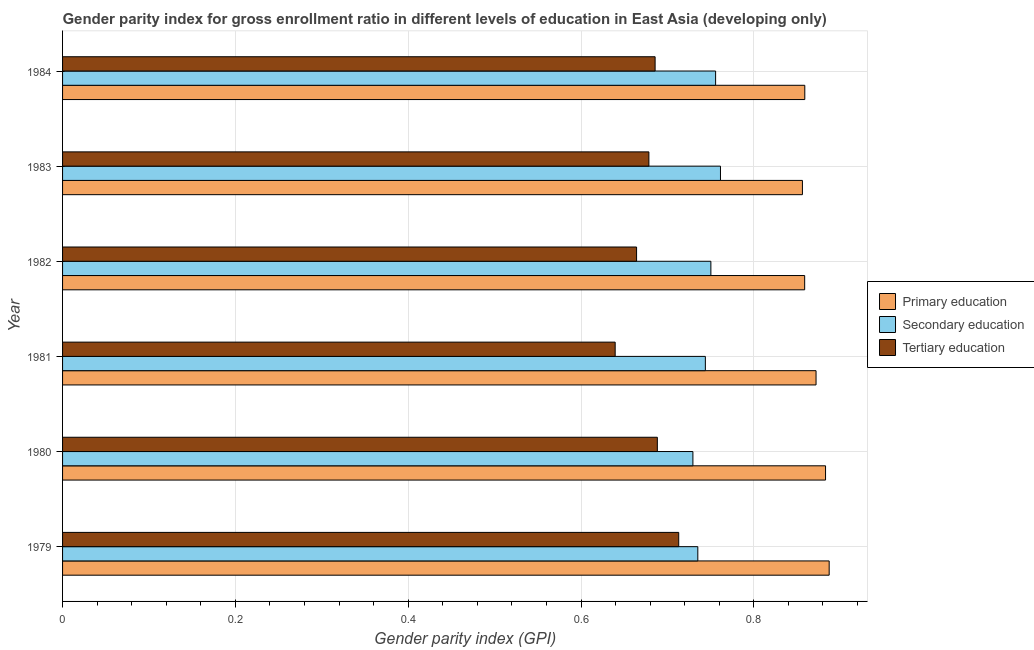Are the number of bars on each tick of the Y-axis equal?
Make the answer very short. Yes. How many bars are there on the 3rd tick from the top?
Give a very brief answer. 3. What is the label of the 1st group of bars from the top?
Provide a succinct answer. 1984. In how many cases, is the number of bars for a given year not equal to the number of legend labels?
Give a very brief answer. 0. What is the gender parity index in tertiary education in 1984?
Provide a succinct answer. 0.69. Across all years, what is the maximum gender parity index in secondary education?
Ensure brevity in your answer.  0.76. Across all years, what is the minimum gender parity index in primary education?
Make the answer very short. 0.86. In which year was the gender parity index in secondary education maximum?
Provide a short and direct response. 1983. What is the total gender parity index in secondary education in the graph?
Your answer should be compact. 4.48. What is the difference between the gender parity index in tertiary education in 1981 and that in 1984?
Keep it short and to the point. -0.05. What is the difference between the gender parity index in tertiary education in 1980 and the gender parity index in primary education in 1982?
Keep it short and to the point. -0.17. What is the average gender parity index in tertiary education per year?
Offer a very short reply. 0.68. In the year 1982, what is the difference between the gender parity index in primary education and gender parity index in tertiary education?
Provide a short and direct response. 0.2. In how many years, is the gender parity index in tertiary education greater than 0.6000000000000001 ?
Your answer should be compact. 6. What is the ratio of the gender parity index in tertiary education in 1981 to that in 1982?
Ensure brevity in your answer.  0.96. Is the gender parity index in tertiary education in 1979 less than that in 1980?
Provide a succinct answer. No. Is the difference between the gender parity index in tertiary education in 1979 and 1984 greater than the difference between the gender parity index in secondary education in 1979 and 1984?
Keep it short and to the point. Yes. What is the difference between the highest and the second highest gender parity index in primary education?
Your answer should be compact. 0. What is the difference between the highest and the lowest gender parity index in tertiary education?
Give a very brief answer. 0.07. In how many years, is the gender parity index in secondary education greater than the average gender parity index in secondary education taken over all years?
Make the answer very short. 3. What does the 2nd bar from the top in 1980 represents?
Your response must be concise. Secondary education. What does the 1st bar from the bottom in 1984 represents?
Provide a succinct answer. Primary education. Is it the case that in every year, the sum of the gender parity index in primary education and gender parity index in secondary education is greater than the gender parity index in tertiary education?
Ensure brevity in your answer.  Yes. How many bars are there?
Your answer should be compact. 18. Are all the bars in the graph horizontal?
Provide a succinct answer. Yes. Where does the legend appear in the graph?
Provide a short and direct response. Center right. How many legend labels are there?
Your answer should be compact. 3. How are the legend labels stacked?
Provide a short and direct response. Vertical. What is the title of the graph?
Your answer should be compact. Gender parity index for gross enrollment ratio in different levels of education in East Asia (developing only). What is the label or title of the X-axis?
Keep it short and to the point. Gender parity index (GPI). What is the Gender parity index (GPI) of Primary education in 1979?
Offer a very short reply. 0.89. What is the Gender parity index (GPI) in Secondary education in 1979?
Offer a terse response. 0.74. What is the Gender parity index (GPI) in Tertiary education in 1979?
Provide a succinct answer. 0.71. What is the Gender parity index (GPI) of Primary education in 1980?
Provide a succinct answer. 0.88. What is the Gender parity index (GPI) of Secondary education in 1980?
Provide a succinct answer. 0.73. What is the Gender parity index (GPI) of Tertiary education in 1980?
Make the answer very short. 0.69. What is the Gender parity index (GPI) of Primary education in 1981?
Offer a terse response. 0.87. What is the Gender parity index (GPI) in Secondary education in 1981?
Make the answer very short. 0.74. What is the Gender parity index (GPI) of Tertiary education in 1981?
Provide a succinct answer. 0.64. What is the Gender parity index (GPI) in Primary education in 1982?
Make the answer very short. 0.86. What is the Gender parity index (GPI) of Secondary education in 1982?
Your response must be concise. 0.75. What is the Gender parity index (GPI) in Tertiary education in 1982?
Your answer should be compact. 0.66. What is the Gender parity index (GPI) in Primary education in 1983?
Make the answer very short. 0.86. What is the Gender parity index (GPI) of Secondary education in 1983?
Keep it short and to the point. 0.76. What is the Gender parity index (GPI) of Tertiary education in 1983?
Your answer should be very brief. 0.68. What is the Gender parity index (GPI) in Primary education in 1984?
Offer a very short reply. 0.86. What is the Gender parity index (GPI) of Secondary education in 1984?
Make the answer very short. 0.76. What is the Gender parity index (GPI) of Tertiary education in 1984?
Provide a short and direct response. 0.69. Across all years, what is the maximum Gender parity index (GPI) in Primary education?
Your answer should be compact. 0.89. Across all years, what is the maximum Gender parity index (GPI) in Secondary education?
Give a very brief answer. 0.76. Across all years, what is the maximum Gender parity index (GPI) of Tertiary education?
Provide a succinct answer. 0.71. Across all years, what is the minimum Gender parity index (GPI) in Primary education?
Provide a short and direct response. 0.86. Across all years, what is the minimum Gender parity index (GPI) in Secondary education?
Offer a terse response. 0.73. Across all years, what is the minimum Gender parity index (GPI) in Tertiary education?
Give a very brief answer. 0.64. What is the total Gender parity index (GPI) in Primary education in the graph?
Ensure brevity in your answer.  5.22. What is the total Gender parity index (GPI) of Secondary education in the graph?
Keep it short and to the point. 4.48. What is the total Gender parity index (GPI) in Tertiary education in the graph?
Make the answer very short. 4.07. What is the difference between the Gender parity index (GPI) of Primary education in 1979 and that in 1980?
Ensure brevity in your answer.  0. What is the difference between the Gender parity index (GPI) in Secondary education in 1979 and that in 1980?
Give a very brief answer. 0.01. What is the difference between the Gender parity index (GPI) in Tertiary education in 1979 and that in 1980?
Keep it short and to the point. 0.02. What is the difference between the Gender parity index (GPI) in Primary education in 1979 and that in 1981?
Ensure brevity in your answer.  0.02. What is the difference between the Gender parity index (GPI) of Secondary education in 1979 and that in 1981?
Give a very brief answer. -0.01. What is the difference between the Gender parity index (GPI) in Tertiary education in 1979 and that in 1981?
Give a very brief answer. 0.07. What is the difference between the Gender parity index (GPI) of Primary education in 1979 and that in 1982?
Your answer should be compact. 0.03. What is the difference between the Gender parity index (GPI) in Secondary education in 1979 and that in 1982?
Ensure brevity in your answer.  -0.02. What is the difference between the Gender parity index (GPI) in Tertiary education in 1979 and that in 1982?
Keep it short and to the point. 0.05. What is the difference between the Gender parity index (GPI) in Primary education in 1979 and that in 1983?
Offer a terse response. 0.03. What is the difference between the Gender parity index (GPI) of Secondary education in 1979 and that in 1983?
Ensure brevity in your answer.  -0.03. What is the difference between the Gender parity index (GPI) of Tertiary education in 1979 and that in 1983?
Your answer should be compact. 0.03. What is the difference between the Gender parity index (GPI) of Primary education in 1979 and that in 1984?
Offer a very short reply. 0.03. What is the difference between the Gender parity index (GPI) in Secondary education in 1979 and that in 1984?
Provide a succinct answer. -0.02. What is the difference between the Gender parity index (GPI) of Tertiary education in 1979 and that in 1984?
Provide a short and direct response. 0.03. What is the difference between the Gender parity index (GPI) of Primary education in 1980 and that in 1981?
Ensure brevity in your answer.  0.01. What is the difference between the Gender parity index (GPI) in Secondary education in 1980 and that in 1981?
Your response must be concise. -0.01. What is the difference between the Gender parity index (GPI) of Tertiary education in 1980 and that in 1981?
Give a very brief answer. 0.05. What is the difference between the Gender parity index (GPI) in Primary education in 1980 and that in 1982?
Offer a very short reply. 0.02. What is the difference between the Gender parity index (GPI) in Secondary education in 1980 and that in 1982?
Keep it short and to the point. -0.02. What is the difference between the Gender parity index (GPI) in Tertiary education in 1980 and that in 1982?
Keep it short and to the point. 0.02. What is the difference between the Gender parity index (GPI) in Primary education in 1980 and that in 1983?
Keep it short and to the point. 0.03. What is the difference between the Gender parity index (GPI) of Secondary education in 1980 and that in 1983?
Ensure brevity in your answer.  -0.03. What is the difference between the Gender parity index (GPI) of Tertiary education in 1980 and that in 1983?
Give a very brief answer. 0.01. What is the difference between the Gender parity index (GPI) in Primary education in 1980 and that in 1984?
Provide a short and direct response. 0.02. What is the difference between the Gender parity index (GPI) in Secondary education in 1980 and that in 1984?
Give a very brief answer. -0.03. What is the difference between the Gender parity index (GPI) of Tertiary education in 1980 and that in 1984?
Offer a terse response. 0. What is the difference between the Gender parity index (GPI) in Primary education in 1981 and that in 1982?
Ensure brevity in your answer.  0.01. What is the difference between the Gender parity index (GPI) of Secondary education in 1981 and that in 1982?
Your answer should be very brief. -0.01. What is the difference between the Gender parity index (GPI) of Tertiary education in 1981 and that in 1982?
Your response must be concise. -0.02. What is the difference between the Gender parity index (GPI) in Primary education in 1981 and that in 1983?
Ensure brevity in your answer.  0.02. What is the difference between the Gender parity index (GPI) of Secondary education in 1981 and that in 1983?
Offer a terse response. -0.02. What is the difference between the Gender parity index (GPI) of Tertiary education in 1981 and that in 1983?
Make the answer very short. -0.04. What is the difference between the Gender parity index (GPI) in Primary education in 1981 and that in 1984?
Ensure brevity in your answer.  0.01. What is the difference between the Gender parity index (GPI) of Secondary education in 1981 and that in 1984?
Provide a succinct answer. -0.01. What is the difference between the Gender parity index (GPI) of Tertiary education in 1981 and that in 1984?
Provide a succinct answer. -0.05. What is the difference between the Gender parity index (GPI) in Primary education in 1982 and that in 1983?
Keep it short and to the point. 0. What is the difference between the Gender parity index (GPI) of Secondary education in 1982 and that in 1983?
Ensure brevity in your answer.  -0.01. What is the difference between the Gender parity index (GPI) in Tertiary education in 1982 and that in 1983?
Keep it short and to the point. -0.01. What is the difference between the Gender parity index (GPI) in Primary education in 1982 and that in 1984?
Provide a short and direct response. -0. What is the difference between the Gender parity index (GPI) in Secondary education in 1982 and that in 1984?
Keep it short and to the point. -0.01. What is the difference between the Gender parity index (GPI) of Tertiary education in 1982 and that in 1984?
Offer a terse response. -0.02. What is the difference between the Gender parity index (GPI) of Primary education in 1983 and that in 1984?
Your answer should be compact. -0. What is the difference between the Gender parity index (GPI) of Secondary education in 1983 and that in 1984?
Offer a very short reply. 0.01. What is the difference between the Gender parity index (GPI) in Tertiary education in 1983 and that in 1984?
Keep it short and to the point. -0.01. What is the difference between the Gender parity index (GPI) of Primary education in 1979 and the Gender parity index (GPI) of Secondary education in 1980?
Give a very brief answer. 0.16. What is the difference between the Gender parity index (GPI) in Primary education in 1979 and the Gender parity index (GPI) in Tertiary education in 1980?
Your answer should be compact. 0.2. What is the difference between the Gender parity index (GPI) of Secondary education in 1979 and the Gender parity index (GPI) of Tertiary education in 1980?
Give a very brief answer. 0.05. What is the difference between the Gender parity index (GPI) of Primary education in 1979 and the Gender parity index (GPI) of Secondary education in 1981?
Offer a very short reply. 0.14. What is the difference between the Gender parity index (GPI) of Primary education in 1979 and the Gender parity index (GPI) of Tertiary education in 1981?
Provide a short and direct response. 0.25. What is the difference between the Gender parity index (GPI) of Secondary education in 1979 and the Gender parity index (GPI) of Tertiary education in 1981?
Your response must be concise. 0.1. What is the difference between the Gender parity index (GPI) in Primary education in 1979 and the Gender parity index (GPI) in Secondary education in 1982?
Your answer should be very brief. 0.14. What is the difference between the Gender parity index (GPI) in Primary education in 1979 and the Gender parity index (GPI) in Tertiary education in 1982?
Provide a succinct answer. 0.22. What is the difference between the Gender parity index (GPI) of Secondary education in 1979 and the Gender parity index (GPI) of Tertiary education in 1982?
Keep it short and to the point. 0.07. What is the difference between the Gender parity index (GPI) in Primary education in 1979 and the Gender parity index (GPI) in Secondary education in 1983?
Offer a terse response. 0.13. What is the difference between the Gender parity index (GPI) in Primary education in 1979 and the Gender parity index (GPI) in Tertiary education in 1983?
Offer a terse response. 0.21. What is the difference between the Gender parity index (GPI) in Secondary education in 1979 and the Gender parity index (GPI) in Tertiary education in 1983?
Keep it short and to the point. 0.06. What is the difference between the Gender parity index (GPI) of Primary education in 1979 and the Gender parity index (GPI) of Secondary education in 1984?
Offer a very short reply. 0.13. What is the difference between the Gender parity index (GPI) in Primary education in 1979 and the Gender parity index (GPI) in Tertiary education in 1984?
Provide a short and direct response. 0.2. What is the difference between the Gender parity index (GPI) of Secondary education in 1979 and the Gender parity index (GPI) of Tertiary education in 1984?
Provide a short and direct response. 0.05. What is the difference between the Gender parity index (GPI) of Primary education in 1980 and the Gender parity index (GPI) of Secondary education in 1981?
Make the answer very short. 0.14. What is the difference between the Gender parity index (GPI) of Primary education in 1980 and the Gender parity index (GPI) of Tertiary education in 1981?
Keep it short and to the point. 0.24. What is the difference between the Gender parity index (GPI) of Secondary education in 1980 and the Gender parity index (GPI) of Tertiary education in 1981?
Offer a very short reply. 0.09. What is the difference between the Gender parity index (GPI) of Primary education in 1980 and the Gender parity index (GPI) of Secondary education in 1982?
Offer a terse response. 0.13. What is the difference between the Gender parity index (GPI) in Primary education in 1980 and the Gender parity index (GPI) in Tertiary education in 1982?
Ensure brevity in your answer.  0.22. What is the difference between the Gender parity index (GPI) of Secondary education in 1980 and the Gender parity index (GPI) of Tertiary education in 1982?
Your response must be concise. 0.07. What is the difference between the Gender parity index (GPI) in Primary education in 1980 and the Gender parity index (GPI) in Secondary education in 1983?
Make the answer very short. 0.12. What is the difference between the Gender parity index (GPI) in Primary education in 1980 and the Gender parity index (GPI) in Tertiary education in 1983?
Ensure brevity in your answer.  0.2. What is the difference between the Gender parity index (GPI) in Secondary education in 1980 and the Gender parity index (GPI) in Tertiary education in 1983?
Your answer should be compact. 0.05. What is the difference between the Gender parity index (GPI) of Primary education in 1980 and the Gender parity index (GPI) of Secondary education in 1984?
Give a very brief answer. 0.13. What is the difference between the Gender parity index (GPI) in Primary education in 1980 and the Gender parity index (GPI) in Tertiary education in 1984?
Provide a short and direct response. 0.2. What is the difference between the Gender parity index (GPI) of Secondary education in 1980 and the Gender parity index (GPI) of Tertiary education in 1984?
Provide a short and direct response. 0.04. What is the difference between the Gender parity index (GPI) of Primary education in 1981 and the Gender parity index (GPI) of Secondary education in 1982?
Keep it short and to the point. 0.12. What is the difference between the Gender parity index (GPI) in Primary education in 1981 and the Gender parity index (GPI) in Tertiary education in 1982?
Your answer should be very brief. 0.21. What is the difference between the Gender parity index (GPI) of Secondary education in 1981 and the Gender parity index (GPI) of Tertiary education in 1982?
Offer a terse response. 0.08. What is the difference between the Gender parity index (GPI) of Primary education in 1981 and the Gender parity index (GPI) of Secondary education in 1983?
Your answer should be compact. 0.11. What is the difference between the Gender parity index (GPI) in Primary education in 1981 and the Gender parity index (GPI) in Tertiary education in 1983?
Give a very brief answer. 0.19. What is the difference between the Gender parity index (GPI) in Secondary education in 1981 and the Gender parity index (GPI) in Tertiary education in 1983?
Your response must be concise. 0.07. What is the difference between the Gender parity index (GPI) in Primary education in 1981 and the Gender parity index (GPI) in Secondary education in 1984?
Give a very brief answer. 0.12. What is the difference between the Gender parity index (GPI) of Primary education in 1981 and the Gender parity index (GPI) of Tertiary education in 1984?
Your response must be concise. 0.19. What is the difference between the Gender parity index (GPI) of Secondary education in 1981 and the Gender parity index (GPI) of Tertiary education in 1984?
Give a very brief answer. 0.06. What is the difference between the Gender parity index (GPI) of Primary education in 1982 and the Gender parity index (GPI) of Secondary education in 1983?
Provide a short and direct response. 0.1. What is the difference between the Gender parity index (GPI) of Primary education in 1982 and the Gender parity index (GPI) of Tertiary education in 1983?
Offer a terse response. 0.18. What is the difference between the Gender parity index (GPI) in Secondary education in 1982 and the Gender parity index (GPI) in Tertiary education in 1983?
Ensure brevity in your answer.  0.07. What is the difference between the Gender parity index (GPI) of Primary education in 1982 and the Gender parity index (GPI) of Secondary education in 1984?
Make the answer very short. 0.1. What is the difference between the Gender parity index (GPI) of Primary education in 1982 and the Gender parity index (GPI) of Tertiary education in 1984?
Give a very brief answer. 0.17. What is the difference between the Gender parity index (GPI) in Secondary education in 1982 and the Gender parity index (GPI) in Tertiary education in 1984?
Your response must be concise. 0.06. What is the difference between the Gender parity index (GPI) of Primary education in 1983 and the Gender parity index (GPI) of Secondary education in 1984?
Provide a short and direct response. 0.1. What is the difference between the Gender parity index (GPI) of Primary education in 1983 and the Gender parity index (GPI) of Tertiary education in 1984?
Offer a very short reply. 0.17. What is the difference between the Gender parity index (GPI) in Secondary education in 1983 and the Gender parity index (GPI) in Tertiary education in 1984?
Provide a succinct answer. 0.08. What is the average Gender parity index (GPI) of Primary education per year?
Ensure brevity in your answer.  0.87. What is the average Gender parity index (GPI) in Secondary education per year?
Your response must be concise. 0.75. What is the average Gender parity index (GPI) in Tertiary education per year?
Offer a very short reply. 0.68. In the year 1979, what is the difference between the Gender parity index (GPI) of Primary education and Gender parity index (GPI) of Secondary education?
Your answer should be compact. 0.15. In the year 1979, what is the difference between the Gender parity index (GPI) of Primary education and Gender parity index (GPI) of Tertiary education?
Your answer should be compact. 0.17. In the year 1979, what is the difference between the Gender parity index (GPI) of Secondary education and Gender parity index (GPI) of Tertiary education?
Provide a short and direct response. 0.02. In the year 1980, what is the difference between the Gender parity index (GPI) in Primary education and Gender parity index (GPI) in Secondary education?
Ensure brevity in your answer.  0.15. In the year 1980, what is the difference between the Gender parity index (GPI) of Primary education and Gender parity index (GPI) of Tertiary education?
Ensure brevity in your answer.  0.19. In the year 1980, what is the difference between the Gender parity index (GPI) in Secondary education and Gender parity index (GPI) in Tertiary education?
Your response must be concise. 0.04. In the year 1981, what is the difference between the Gender parity index (GPI) of Primary education and Gender parity index (GPI) of Secondary education?
Offer a very short reply. 0.13. In the year 1981, what is the difference between the Gender parity index (GPI) of Primary education and Gender parity index (GPI) of Tertiary education?
Your response must be concise. 0.23. In the year 1981, what is the difference between the Gender parity index (GPI) of Secondary education and Gender parity index (GPI) of Tertiary education?
Ensure brevity in your answer.  0.1. In the year 1982, what is the difference between the Gender parity index (GPI) in Primary education and Gender parity index (GPI) in Secondary education?
Provide a short and direct response. 0.11. In the year 1982, what is the difference between the Gender parity index (GPI) in Primary education and Gender parity index (GPI) in Tertiary education?
Ensure brevity in your answer.  0.19. In the year 1982, what is the difference between the Gender parity index (GPI) in Secondary education and Gender parity index (GPI) in Tertiary education?
Offer a terse response. 0.09. In the year 1983, what is the difference between the Gender parity index (GPI) in Primary education and Gender parity index (GPI) in Secondary education?
Your response must be concise. 0.09. In the year 1983, what is the difference between the Gender parity index (GPI) of Primary education and Gender parity index (GPI) of Tertiary education?
Make the answer very short. 0.18. In the year 1983, what is the difference between the Gender parity index (GPI) of Secondary education and Gender parity index (GPI) of Tertiary education?
Provide a succinct answer. 0.08. In the year 1984, what is the difference between the Gender parity index (GPI) of Primary education and Gender parity index (GPI) of Secondary education?
Keep it short and to the point. 0.1. In the year 1984, what is the difference between the Gender parity index (GPI) of Primary education and Gender parity index (GPI) of Tertiary education?
Your answer should be very brief. 0.17. In the year 1984, what is the difference between the Gender parity index (GPI) in Secondary education and Gender parity index (GPI) in Tertiary education?
Ensure brevity in your answer.  0.07. What is the ratio of the Gender parity index (GPI) in Primary education in 1979 to that in 1980?
Make the answer very short. 1. What is the ratio of the Gender parity index (GPI) of Tertiary education in 1979 to that in 1980?
Offer a terse response. 1.04. What is the ratio of the Gender parity index (GPI) of Primary education in 1979 to that in 1981?
Make the answer very short. 1.02. What is the ratio of the Gender parity index (GPI) in Secondary education in 1979 to that in 1981?
Keep it short and to the point. 0.99. What is the ratio of the Gender parity index (GPI) in Tertiary education in 1979 to that in 1981?
Give a very brief answer. 1.11. What is the ratio of the Gender parity index (GPI) of Primary education in 1979 to that in 1982?
Offer a terse response. 1.03. What is the ratio of the Gender parity index (GPI) in Secondary education in 1979 to that in 1982?
Give a very brief answer. 0.98. What is the ratio of the Gender parity index (GPI) of Tertiary education in 1979 to that in 1982?
Your response must be concise. 1.07. What is the ratio of the Gender parity index (GPI) of Primary education in 1979 to that in 1983?
Provide a succinct answer. 1.04. What is the ratio of the Gender parity index (GPI) of Secondary education in 1979 to that in 1983?
Ensure brevity in your answer.  0.97. What is the ratio of the Gender parity index (GPI) of Tertiary education in 1979 to that in 1983?
Provide a succinct answer. 1.05. What is the ratio of the Gender parity index (GPI) of Primary education in 1979 to that in 1984?
Make the answer very short. 1.03. What is the ratio of the Gender parity index (GPI) in Secondary education in 1979 to that in 1984?
Provide a succinct answer. 0.97. What is the ratio of the Gender parity index (GPI) of Tertiary education in 1979 to that in 1984?
Make the answer very short. 1.04. What is the ratio of the Gender parity index (GPI) of Primary education in 1980 to that in 1981?
Give a very brief answer. 1.01. What is the ratio of the Gender parity index (GPI) in Secondary education in 1980 to that in 1981?
Ensure brevity in your answer.  0.98. What is the ratio of the Gender parity index (GPI) in Tertiary education in 1980 to that in 1981?
Offer a very short reply. 1.08. What is the ratio of the Gender parity index (GPI) in Primary education in 1980 to that in 1982?
Your answer should be very brief. 1.03. What is the ratio of the Gender parity index (GPI) in Secondary education in 1980 to that in 1982?
Make the answer very short. 0.97. What is the ratio of the Gender parity index (GPI) in Tertiary education in 1980 to that in 1982?
Provide a short and direct response. 1.04. What is the ratio of the Gender parity index (GPI) in Primary education in 1980 to that in 1983?
Keep it short and to the point. 1.03. What is the ratio of the Gender parity index (GPI) of Secondary education in 1980 to that in 1983?
Give a very brief answer. 0.96. What is the ratio of the Gender parity index (GPI) in Tertiary education in 1980 to that in 1983?
Your answer should be very brief. 1.01. What is the ratio of the Gender parity index (GPI) in Primary education in 1980 to that in 1984?
Your answer should be very brief. 1.03. What is the ratio of the Gender parity index (GPI) of Secondary education in 1980 to that in 1984?
Ensure brevity in your answer.  0.97. What is the ratio of the Gender parity index (GPI) of Primary education in 1981 to that in 1982?
Offer a very short reply. 1.02. What is the ratio of the Gender parity index (GPI) in Tertiary education in 1981 to that in 1982?
Ensure brevity in your answer.  0.96. What is the ratio of the Gender parity index (GPI) of Primary education in 1981 to that in 1983?
Keep it short and to the point. 1.02. What is the ratio of the Gender parity index (GPI) of Secondary education in 1981 to that in 1983?
Give a very brief answer. 0.98. What is the ratio of the Gender parity index (GPI) of Tertiary education in 1981 to that in 1983?
Your response must be concise. 0.94. What is the ratio of the Gender parity index (GPI) of Primary education in 1981 to that in 1984?
Ensure brevity in your answer.  1.02. What is the ratio of the Gender parity index (GPI) in Secondary education in 1981 to that in 1984?
Offer a very short reply. 0.98. What is the ratio of the Gender parity index (GPI) of Tertiary education in 1981 to that in 1984?
Give a very brief answer. 0.93. What is the ratio of the Gender parity index (GPI) in Secondary education in 1982 to that in 1983?
Your response must be concise. 0.99. What is the ratio of the Gender parity index (GPI) of Tertiary education in 1982 to that in 1983?
Your response must be concise. 0.98. What is the ratio of the Gender parity index (GPI) in Secondary education in 1982 to that in 1984?
Your answer should be compact. 0.99. What is the ratio of the Gender parity index (GPI) of Tertiary education in 1982 to that in 1984?
Offer a very short reply. 0.97. What is the ratio of the Gender parity index (GPI) of Primary education in 1983 to that in 1984?
Provide a succinct answer. 1. What is the ratio of the Gender parity index (GPI) in Secondary education in 1983 to that in 1984?
Provide a succinct answer. 1.01. What is the difference between the highest and the second highest Gender parity index (GPI) in Primary education?
Keep it short and to the point. 0. What is the difference between the highest and the second highest Gender parity index (GPI) of Secondary education?
Keep it short and to the point. 0.01. What is the difference between the highest and the second highest Gender parity index (GPI) in Tertiary education?
Give a very brief answer. 0.02. What is the difference between the highest and the lowest Gender parity index (GPI) of Primary education?
Ensure brevity in your answer.  0.03. What is the difference between the highest and the lowest Gender parity index (GPI) of Secondary education?
Offer a terse response. 0.03. What is the difference between the highest and the lowest Gender parity index (GPI) in Tertiary education?
Give a very brief answer. 0.07. 